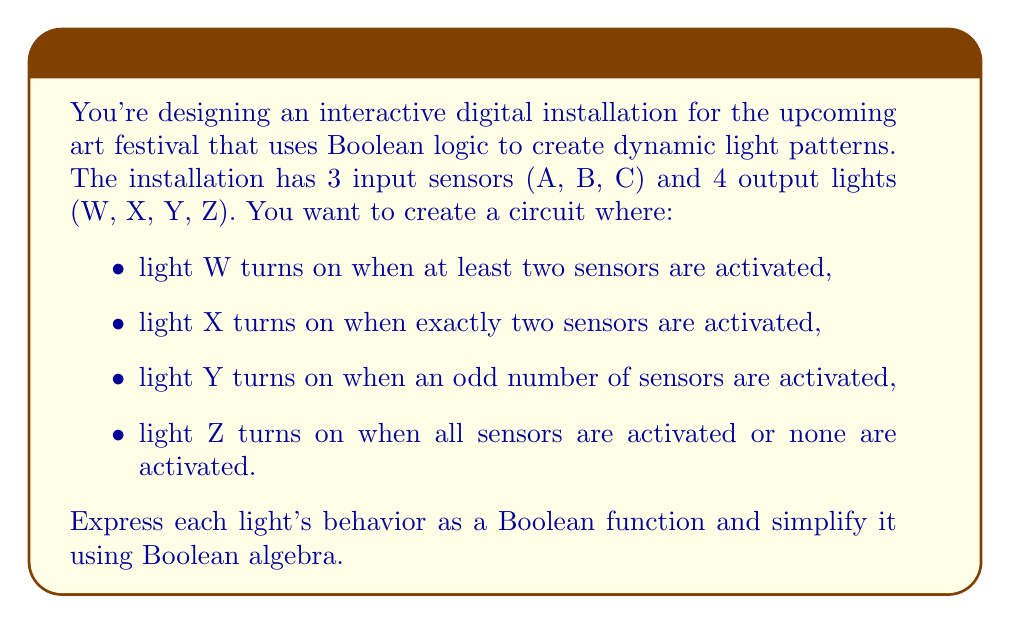Give your solution to this math problem. Let's approach this step-by-step:

1) For light W (at least two sensors activated):
   $$W = AB + AC + BC$$
   This is already in its simplest form.

2) For light X (exactly two sensors activated):
   $$X = AB\bar{C} + AC\bar{B} + BC\bar{A}$$
   This is also in its simplest form.

3) For light Y (odd number of sensors activated):
   $$Y = A \oplus B \oplus C$$
   Where $\oplus$ represents XOR. This can be expanded as:
   $$Y = A\bar{B}\bar{C} + \bar{A}B\bar{C} + \bar{A}\bar{B}C + ABC$$
   This is the simplest form for this function.

4) For light Z (all sensors activated or none activated):
   $$Z = ABC + \bar{A}\bar{B}\bar{C}$$
   This can be simplified using the following steps:
   $$Z = ABC + \bar{A}\bar{B}\bar{C}$$
   $$= (A + \bar{A})(B + \bar{B})(C + \bar{C}) - (A\bar{B}\bar{C} + \bar{A}B\bar{C} + \bar{A}\bar{B}C + AB\bar{C} + A\bar{B}C + \bar{A}BC)$$
   $$= 1 - (A \oplus B \oplus C)$$
   $$= \overline{A \oplus B \oplus C}$$

   This last form is the simplest expression for Z, showing that it's the complement of Y.

These Boolean functions can be implemented using logic gates to control the lights in your installation.
Answer: W = AB + AC + BC
X = AB\bar{C} + AC\bar{B} + BC\bar{A}
Y = A \oplus B \oplus C
Z = \overline{A \oplus B \oplus C} 